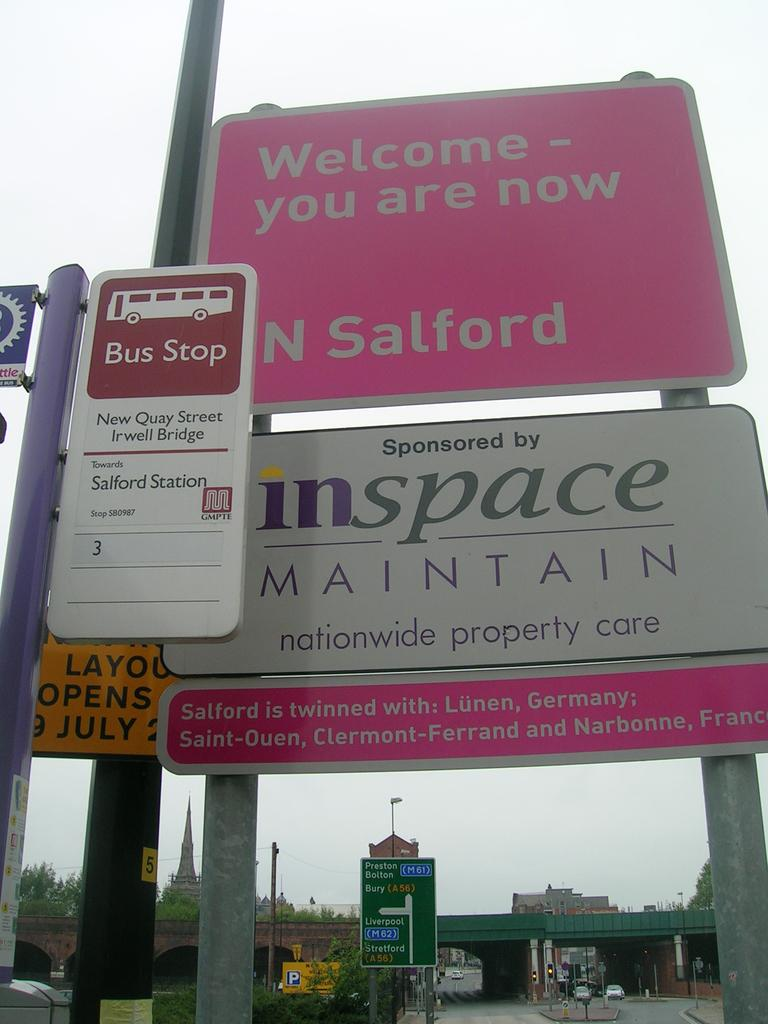<image>
Present a compact description of the photo's key features. Pink street sign that says "Welcome you are now". 